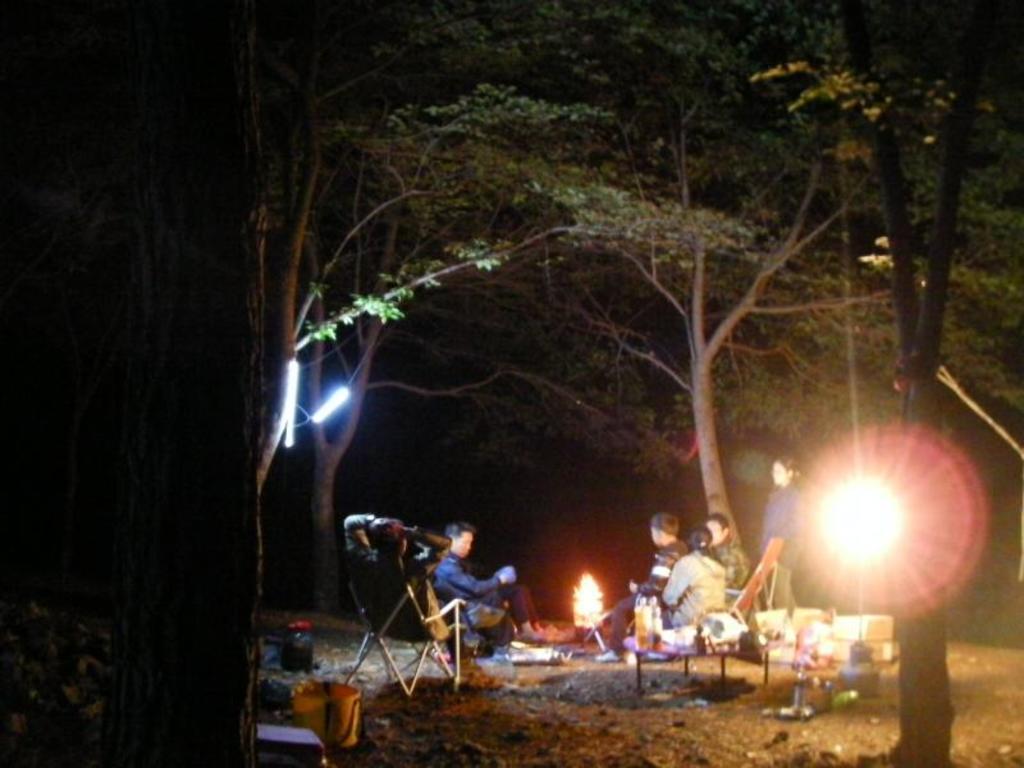Can you describe this image briefly? Here in this picture we can see some people sitting on chairs present on ground and in the middle of them we can see a campfire present and behind them we can see a table with some items present and we can also see lights present and we can see the ground is covered with grass and we can also see trees covered over there. 